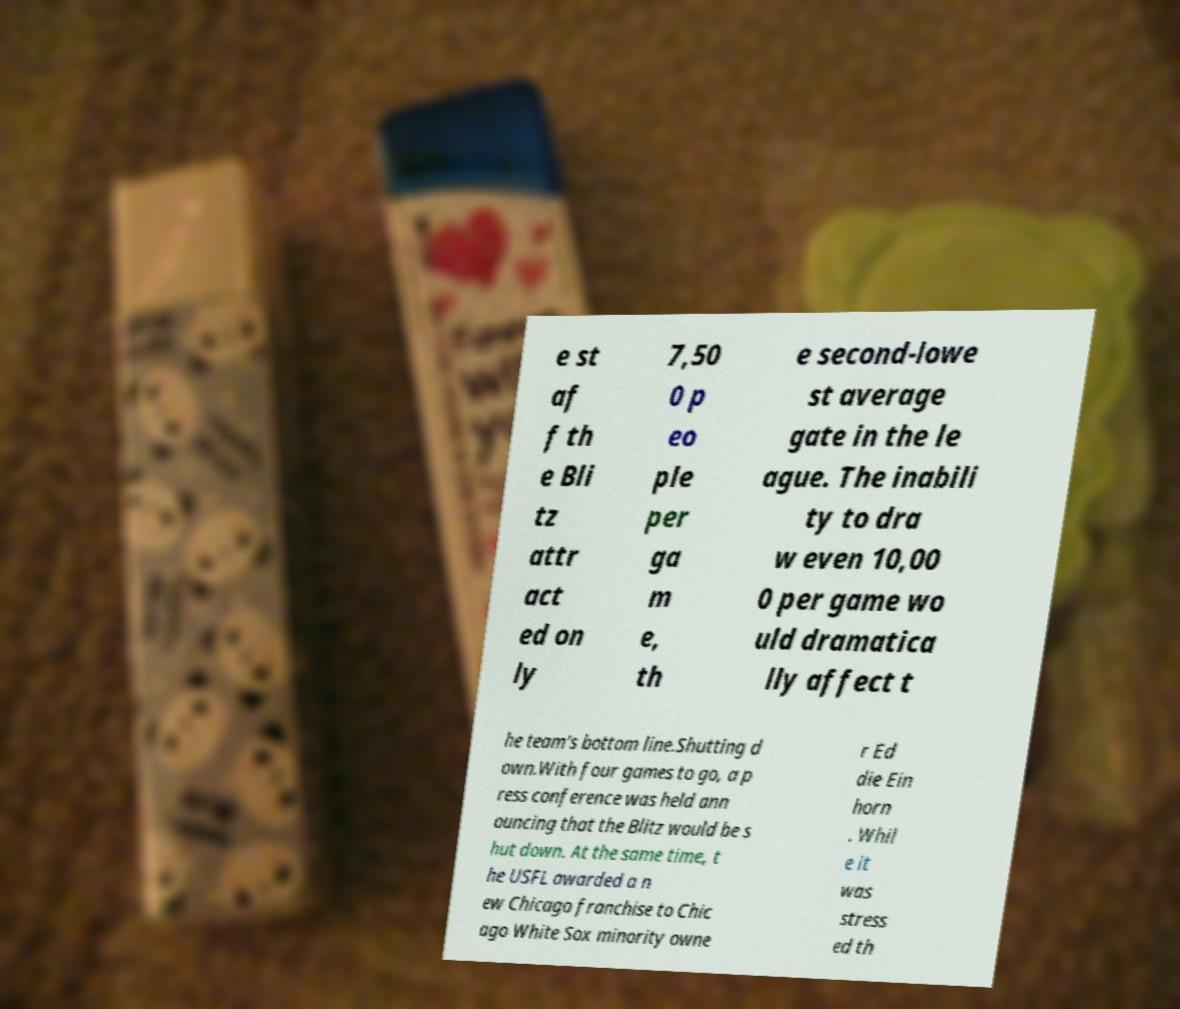There's text embedded in this image that I need extracted. Can you transcribe it verbatim? e st af f th e Bli tz attr act ed on ly 7,50 0 p eo ple per ga m e, th e second-lowe st average gate in the le ague. The inabili ty to dra w even 10,00 0 per game wo uld dramatica lly affect t he team's bottom line.Shutting d own.With four games to go, a p ress conference was held ann ouncing that the Blitz would be s hut down. At the same time, t he USFL awarded a n ew Chicago franchise to Chic ago White Sox minority owne r Ed die Ein horn . Whil e it was stress ed th 